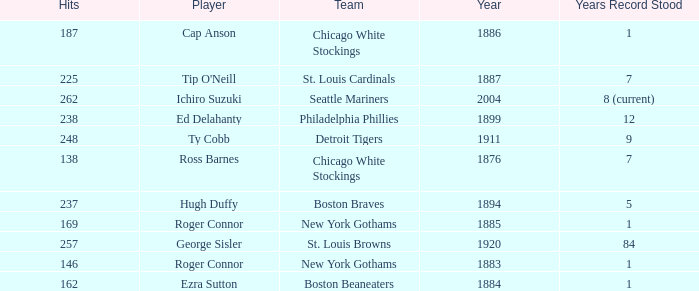Name the least hits for year less than 1920 and player of ed delahanty 238.0. 